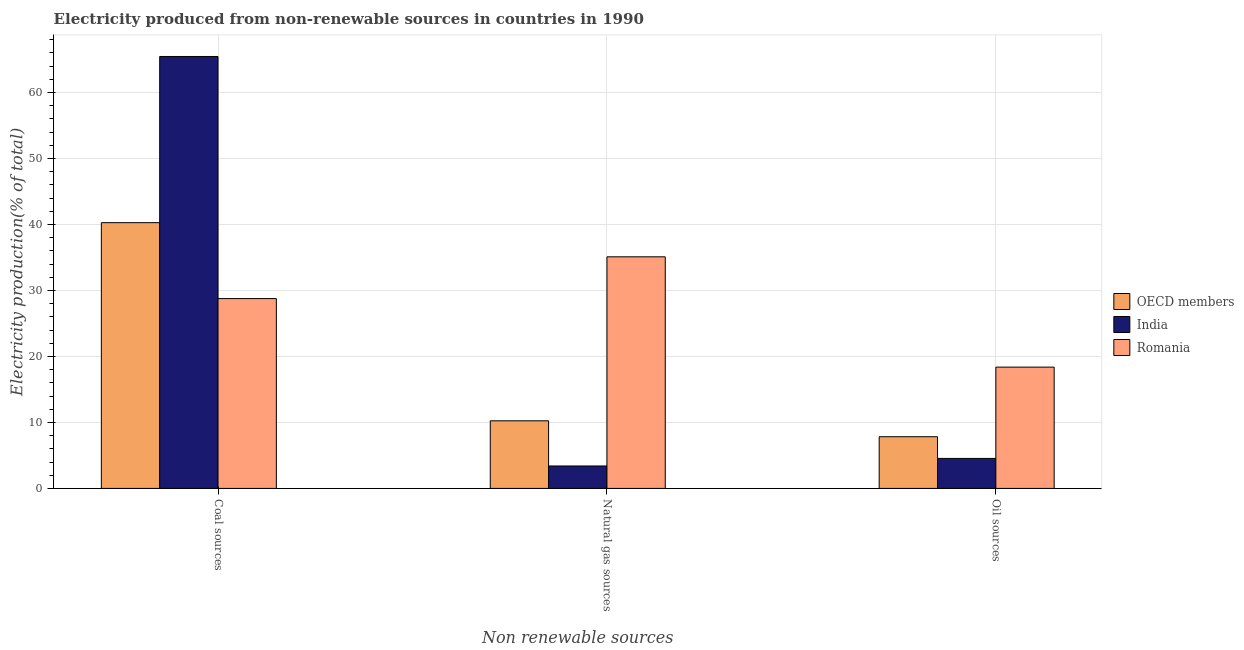How many different coloured bars are there?
Your answer should be very brief. 3. How many groups of bars are there?
Your answer should be very brief. 3. What is the label of the 3rd group of bars from the left?
Offer a terse response. Oil sources. What is the percentage of electricity produced by oil sources in India?
Keep it short and to the point. 4.55. Across all countries, what is the maximum percentage of electricity produced by natural gas?
Your answer should be compact. 35.1. Across all countries, what is the minimum percentage of electricity produced by coal?
Ensure brevity in your answer.  28.77. In which country was the percentage of electricity produced by oil sources maximum?
Make the answer very short. Romania. What is the total percentage of electricity produced by coal in the graph?
Your response must be concise. 134.51. What is the difference between the percentage of electricity produced by natural gas in Romania and that in OECD members?
Your answer should be very brief. 24.85. What is the difference between the percentage of electricity produced by natural gas in India and the percentage of electricity produced by oil sources in OECD members?
Your answer should be very brief. -4.43. What is the average percentage of electricity produced by oil sources per country?
Make the answer very short. 10.25. What is the difference between the percentage of electricity produced by oil sources and percentage of electricity produced by coal in OECD members?
Provide a short and direct response. -32.44. In how many countries, is the percentage of electricity produced by coal greater than 34 %?
Provide a succinct answer. 2. What is the ratio of the percentage of electricity produced by oil sources in OECD members to that in Romania?
Offer a terse response. 0.43. What is the difference between the highest and the second highest percentage of electricity produced by natural gas?
Provide a short and direct response. 24.85. What is the difference between the highest and the lowest percentage of electricity produced by coal?
Your answer should be compact. 36.69. What does the 3rd bar from the right in Natural gas sources represents?
Your answer should be compact. OECD members. How many countries are there in the graph?
Offer a very short reply. 3. What is the difference between two consecutive major ticks on the Y-axis?
Provide a succinct answer. 10. Does the graph contain any zero values?
Provide a succinct answer. No. How many legend labels are there?
Your answer should be compact. 3. What is the title of the graph?
Make the answer very short. Electricity produced from non-renewable sources in countries in 1990. Does "Guam" appear as one of the legend labels in the graph?
Keep it short and to the point. No. What is the label or title of the X-axis?
Provide a short and direct response. Non renewable sources. What is the label or title of the Y-axis?
Make the answer very short. Electricity production(% of total). What is the Electricity production(% of total) of OECD members in Coal sources?
Keep it short and to the point. 40.28. What is the Electricity production(% of total) of India in Coal sources?
Your response must be concise. 65.46. What is the Electricity production(% of total) in Romania in Coal sources?
Your response must be concise. 28.77. What is the Electricity production(% of total) in OECD members in Natural gas sources?
Offer a very short reply. 10.25. What is the Electricity production(% of total) of India in Natural gas sources?
Make the answer very short. 3.4. What is the Electricity production(% of total) in Romania in Natural gas sources?
Ensure brevity in your answer.  35.1. What is the Electricity production(% of total) of OECD members in Oil sources?
Provide a succinct answer. 7.83. What is the Electricity production(% of total) in India in Oil sources?
Provide a short and direct response. 4.55. What is the Electricity production(% of total) in Romania in Oil sources?
Keep it short and to the point. 18.38. Across all Non renewable sources, what is the maximum Electricity production(% of total) in OECD members?
Your answer should be very brief. 40.28. Across all Non renewable sources, what is the maximum Electricity production(% of total) in India?
Offer a terse response. 65.46. Across all Non renewable sources, what is the maximum Electricity production(% of total) of Romania?
Offer a very short reply. 35.1. Across all Non renewable sources, what is the minimum Electricity production(% of total) of OECD members?
Give a very brief answer. 7.83. Across all Non renewable sources, what is the minimum Electricity production(% of total) of India?
Your answer should be compact. 3.4. Across all Non renewable sources, what is the minimum Electricity production(% of total) in Romania?
Your response must be concise. 18.38. What is the total Electricity production(% of total) in OECD members in the graph?
Keep it short and to the point. 58.36. What is the total Electricity production(% of total) in India in the graph?
Make the answer very short. 73.41. What is the total Electricity production(% of total) in Romania in the graph?
Provide a short and direct response. 82.26. What is the difference between the Electricity production(% of total) in OECD members in Coal sources and that in Natural gas sources?
Provide a short and direct response. 30.03. What is the difference between the Electricity production(% of total) in India in Coal sources and that in Natural gas sources?
Provide a succinct answer. 62.06. What is the difference between the Electricity production(% of total) of Romania in Coal sources and that in Natural gas sources?
Your response must be concise. -6.33. What is the difference between the Electricity production(% of total) of OECD members in Coal sources and that in Oil sources?
Give a very brief answer. 32.44. What is the difference between the Electricity production(% of total) of India in Coal sources and that in Oil sources?
Provide a succinct answer. 60.92. What is the difference between the Electricity production(% of total) in Romania in Coal sources and that in Oil sources?
Make the answer very short. 10.39. What is the difference between the Electricity production(% of total) of OECD members in Natural gas sources and that in Oil sources?
Your answer should be compact. 2.41. What is the difference between the Electricity production(% of total) in India in Natural gas sources and that in Oil sources?
Provide a short and direct response. -1.15. What is the difference between the Electricity production(% of total) in Romania in Natural gas sources and that in Oil sources?
Offer a terse response. 16.72. What is the difference between the Electricity production(% of total) of OECD members in Coal sources and the Electricity production(% of total) of India in Natural gas sources?
Keep it short and to the point. 36.87. What is the difference between the Electricity production(% of total) of OECD members in Coal sources and the Electricity production(% of total) of Romania in Natural gas sources?
Keep it short and to the point. 5.18. What is the difference between the Electricity production(% of total) in India in Coal sources and the Electricity production(% of total) in Romania in Natural gas sources?
Offer a terse response. 30.36. What is the difference between the Electricity production(% of total) of OECD members in Coal sources and the Electricity production(% of total) of India in Oil sources?
Offer a terse response. 35.73. What is the difference between the Electricity production(% of total) of OECD members in Coal sources and the Electricity production(% of total) of Romania in Oil sources?
Ensure brevity in your answer.  21.89. What is the difference between the Electricity production(% of total) of India in Coal sources and the Electricity production(% of total) of Romania in Oil sources?
Your answer should be very brief. 47.08. What is the difference between the Electricity production(% of total) in OECD members in Natural gas sources and the Electricity production(% of total) in Romania in Oil sources?
Keep it short and to the point. -8.14. What is the difference between the Electricity production(% of total) in India in Natural gas sources and the Electricity production(% of total) in Romania in Oil sources?
Offer a very short reply. -14.98. What is the average Electricity production(% of total) of OECD members per Non renewable sources?
Offer a terse response. 19.45. What is the average Electricity production(% of total) of India per Non renewable sources?
Offer a terse response. 24.47. What is the average Electricity production(% of total) in Romania per Non renewable sources?
Your answer should be compact. 27.42. What is the difference between the Electricity production(% of total) of OECD members and Electricity production(% of total) of India in Coal sources?
Provide a short and direct response. -25.19. What is the difference between the Electricity production(% of total) in OECD members and Electricity production(% of total) in Romania in Coal sources?
Offer a terse response. 11.51. What is the difference between the Electricity production(% of total) in India and Electricity production(% of total) in Romania in Coal sources?
Provide a succinct answer. 36.69. What is the difference between the Electricity production(% of total) in OECD members and Electricity production(% of total) in India in Natural gas sources?
Make the answer very short. 6.85. What is the difference between the Electricity production(% of total) of OECD members and Electricity production(% of total) of Romania in Natural gas sources?
Offer a terse response. -24.85. What is the difference between the Electricity production(% of total) in India and Electricity production(% of total) in Romania in Natural gas sources?
Your answer should be very brief. -31.7. What is the difference between the Electricity production(% of total) of OECD members and Electricity production(% of total) of India in Oil sources?
Offer a very short reply. 3.29. What is the difference between the Electricity production(% of total) in OECD members and Electricity production(% of total) in Romania in Oil sources?
Keep it short and to the point. -10.55. What is the difference between the Electricity production(% of total) in India and Electricity production(% of total) in Romania in Oil sources?
Your response must be concise. -13.84. What is the ratio of the Electricity production(% of total) in OECD members in Coal sources to that in Natural gas sources?
Provide a succinct answer. 3.93. What is the ratio of the Electricity production(% of total) in India in Coal sources to that in Natural gas sources?
Keep it short and to the point. 19.24. What is the ratio of the Electricity production(% of total) of Romania in Coal sources to that in Natural gas sources?
Offer a very short reply. 0.82. What is the ratio of the Electricity production(% of total) in OECD members in Coal sources to that in Oil sources?
Ensure brevity in your answer.  5.14. What is the ratio of the Electricity production(% of total) of India in Coal sources to that in Oil sources?
Make the answer very short. 14.4. What is the ratio of the Electricity production(% of total) of Romania in Coal sources to that in Oil sources?
Provide a short and direct response. 1.56. What is the ratio of the Electricity production(% of total) of OECD members in Natural gas sources to that in Oil sources?
Give a very brief answer. 1.31. What is the ratio of the Electricity production(% of total) in India in Natural gas sources to that in Oil sources?
Offer a very short reply. 0.75. What is the ratio of the Electricity production(% of total) in Romania in Natural gas sources to that in Oil sources?
Give a very brief answer. 1.91. What is the difference between the highest and the second highest Electricity production(% of total) of OECD members?
Your answer should be very brief. 30.03. What is the difference between the highest and the second highest Electricity production(% of total) in India?
Give a very brief answer. 60.92. What is the difference between the highest and the second highest Electricity production(% of total) in Romania?
Ensure brevity in your answer.  6.33. What is the difference between the highest and the lowest Electricity production(% of total) in OECD members?
Give a very brief answer. 32.44. What is the difference between the highest and the lowest Electricity production(% of total) of India?
Make the answer very short. 62.06. What is the difference between the highest and the lowest Electricity production(% of total) in Romania?
Ensure brevity in your answer.  16.72. 